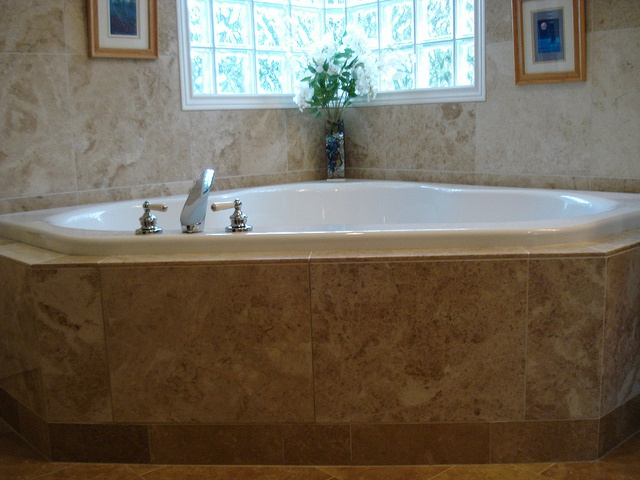Describe the objects in this image and their specific colors. I can see sink in gray, darkgray, and lightblue tones, potted plant in gray, lightblue, and black tones, and vase in gray, black, teal, and navy tones in this image. 